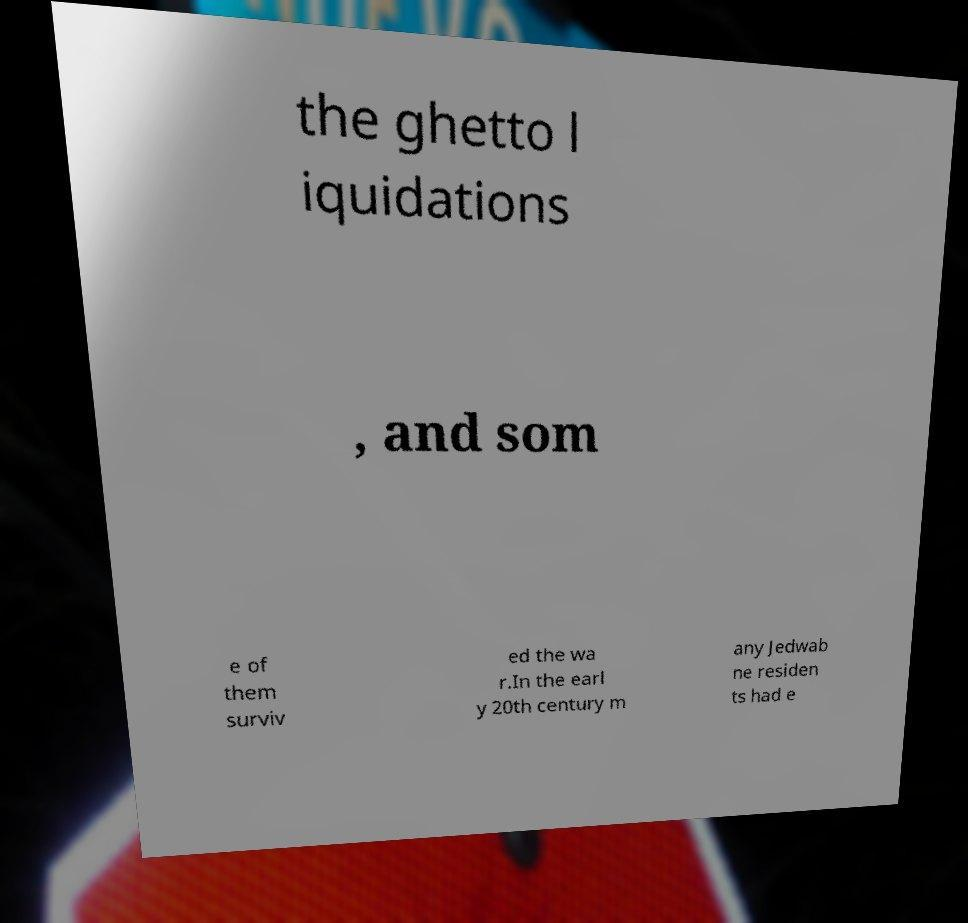For documentation purposes, I need the text within this image transcribed. Could you provide that? the ghetto l iquidations , and som e of them surviv ed the wa r.In the earl y 20th century m any Jedwab ne residen ts had e 